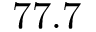Convert formula to latex. <formula><loc_0><loc_0><loc_500><loc_500>7 7 . 7</formula> 